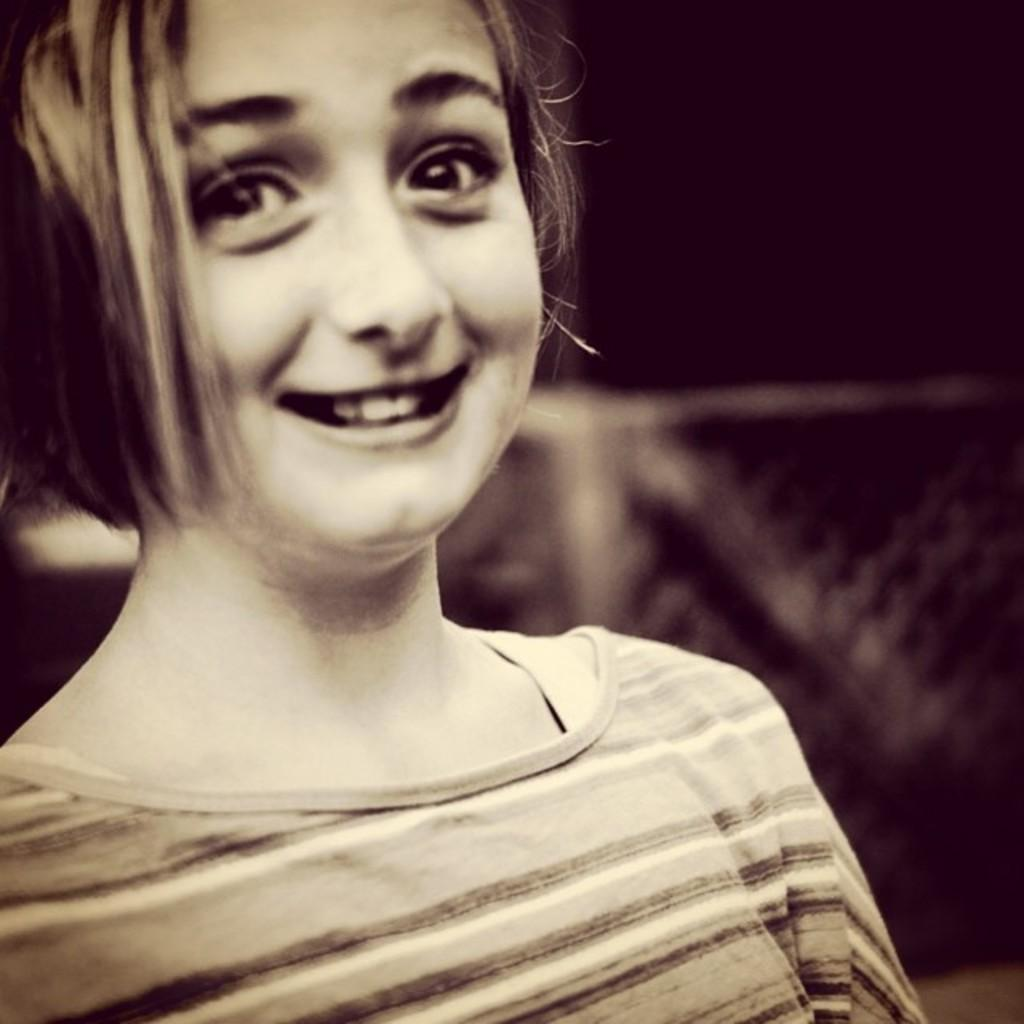What is the color scheme of the image? The image is black and white. Who or what is the main subject in the image? There is a girl in the image. What can be observed about the background of the image? The background of the image is dark. What type of cushion is the girl sitting on in the image? There is no cushion present in the image, as it is a black and white image and the focus is on the girl and the dark background. 